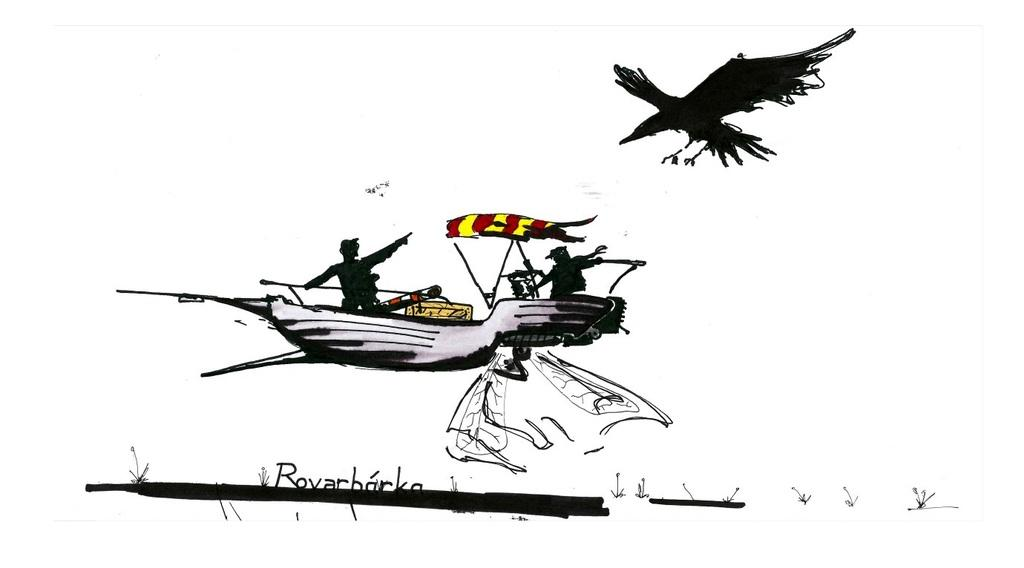What is depicted in the image? The image contains a sketch of persons, a boat, and a bird. What is the color of the background in the image? The background of the image is white in color. Is there any text present in the image? Yes, there is text on the image. What type of plastic material is used to create the boat in the image? There is no indication in the image that the boat is made of plastic, as it is a sketch and not a photograph of a real object. 